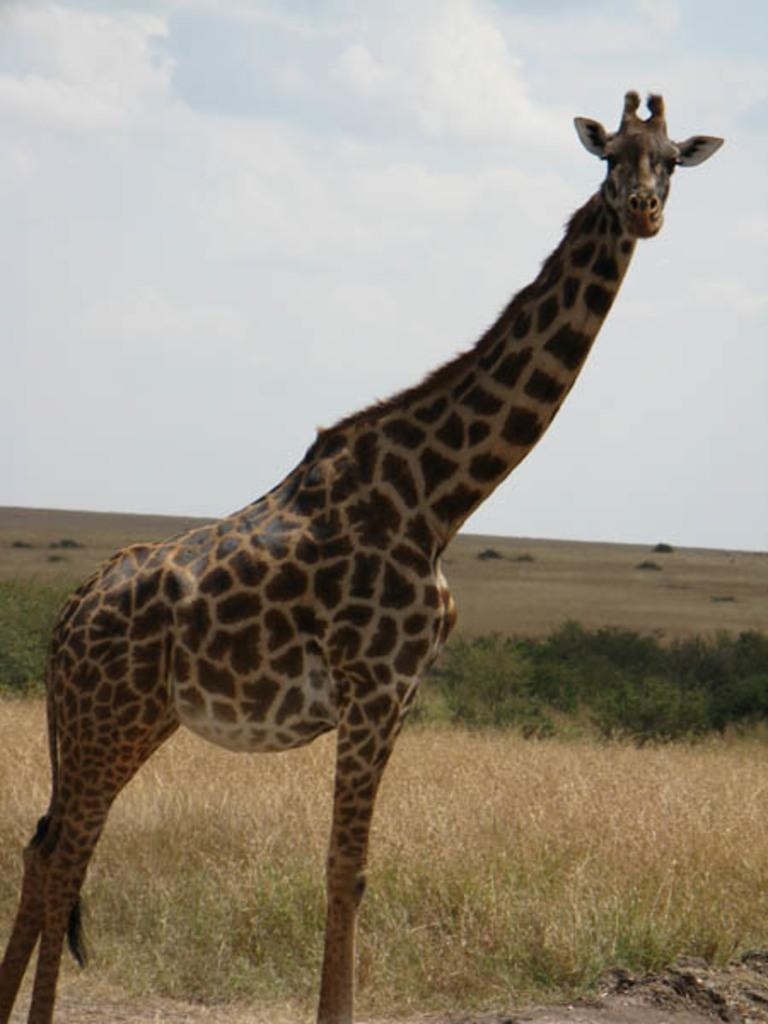What animal is in the center of the image? There is a giraffe in the center of the image. What can be seen in the background of the image? There is greenery in the background of the image. What type of butter is being used to lubricate the pipe in the image? There is no butter or pipe present in the image; it features a giraffe and greenery in the background. 